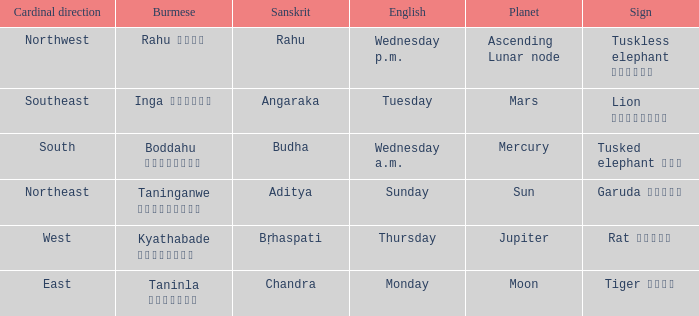State the name of day in english where cardinal direction is east Monday. 